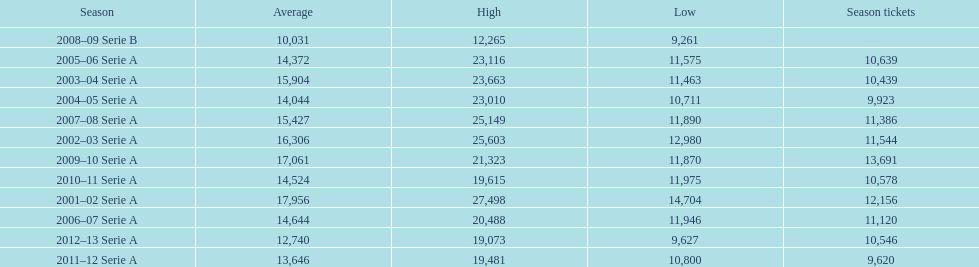What was the average in 2001 17,956. 